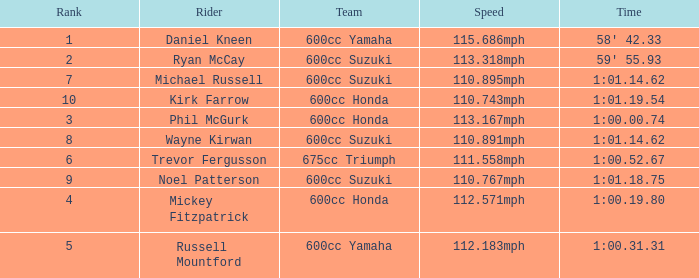How many ranks have 1:01.14.62 as the time, with michael russell as the rider? 1.0. 